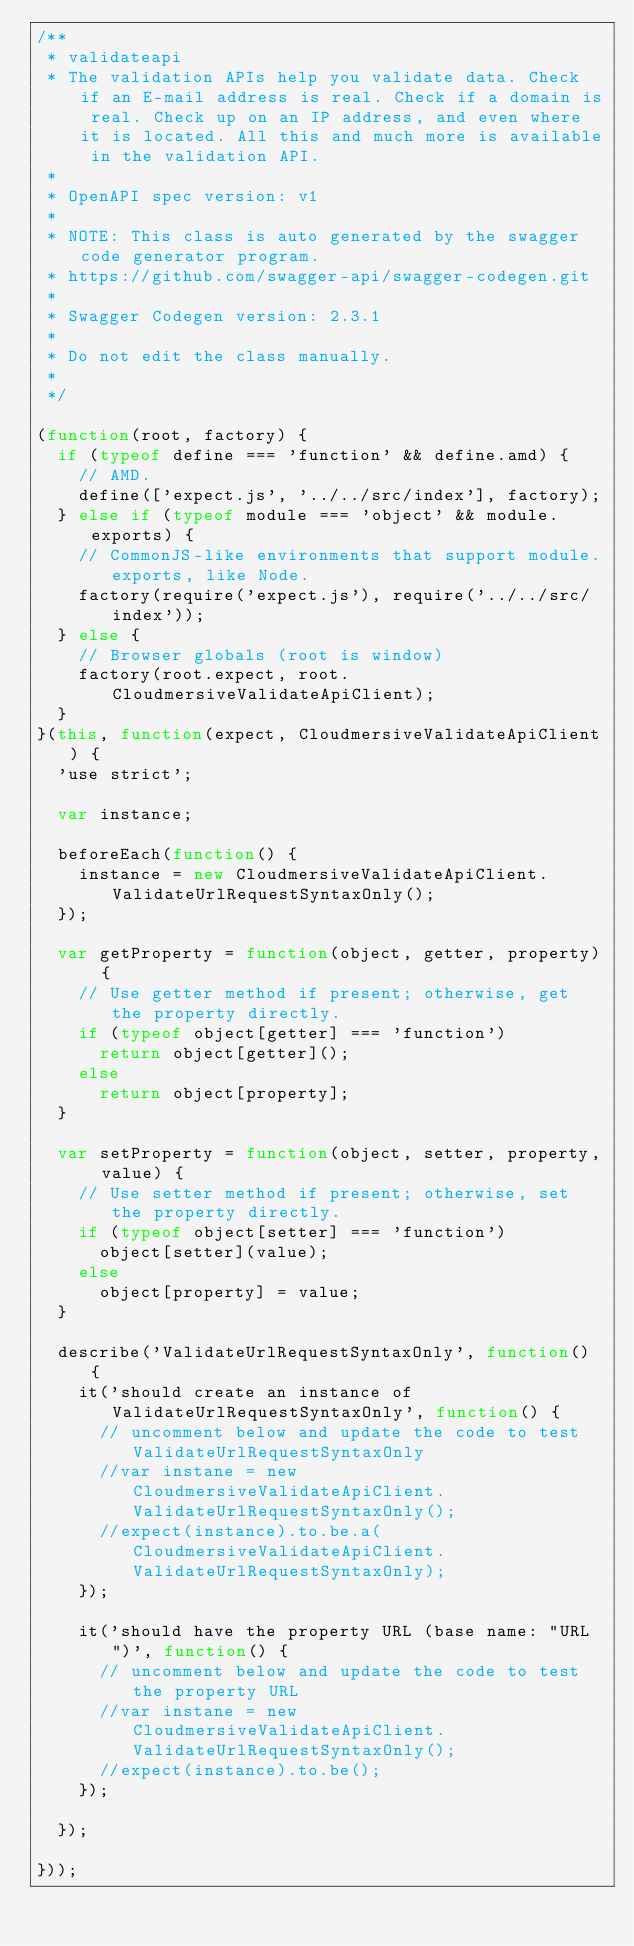Convert code to text. <code><loc_0><loc_0><loc_500><loc_500><_JavaScript_>/**
 * validateapi
 * The validation APIs help you validate data. Check if an E-mail address is real. Check if a domain is real. Check up on an IP address, and even where it is located. All this and much more is available in the validation API.
 *
 * OpenAPI spec version: v1
 *
 * NOTE: This class is auto generated by the swagger code generator program.
 * https://github.com/swagger-api/swagger-codegen.git
 *
 * Swagger Codegen version: 2.3.1
 *
 * Do not edit the class manually.
 *
 */

(function(root, factory) {
  if (typeof define === 'function' && define.amd) {
    // AMD.
    define(['expect.js', '../../src/index'], factory);
  } else if (typeof module === 'object' && module.exports) {
    // CommonJS-like environments that support module.exports, like Node.
    factory(require('expect.js'), require('../../src/index'));
  } else {
    // Browser globals (root is window)
    factory(root.expect, root.CloudmersiveValidateApiClient);
  }
}(this, function(expect, CloudmersiveValidateApiClient) {
  'use strict';

  var instance;

  beforeEach(function() {
    instance = new CloudmersiveValidateApiClient.ValidateUrlRequestSyntaxOnly();
  });

  var getProperty = function(object, getter, property) {
    // Use getter method if present; otherwise, get the property directly.
    if (typeof object[getter] === 'function')
      return object[getter]();
    else
      return object[property];
  }

  var setProperty = function(object, setter, property, value) {
    // Use setter method if present; otherwise, set the property directly.
    if (typeof object[setter] === 'function')
      object[setter](value);
    else
      object[property] = value;
  }

  describe('ValidateUrlRequestSyntaxOnly', function() {
    it('should create an instance of ValidateUrlRequestSyntaxOnly', function() {
      // uncomment below and update the code to test ValidateUrlRequestSyntaxOnly
      //var instane = new CloudmersiveValidateApiClient.ValidateUrlRequestSyntaxOnly();
      //expect(instance).to.be.a(CloudmersiveValidateApiClient.ValidateUrlRequestSyntaxOnly);
    });

    it('should have the property URL (base name: "URL")', function() {
      // uncomment below and update the code to test the property URL
      //var instane = new CloudmersiveValidateApiClient.ValidateUrlRequestSyntaxOnly();
      //expect(instance).to.be();
    });

  });

}));
</code> 